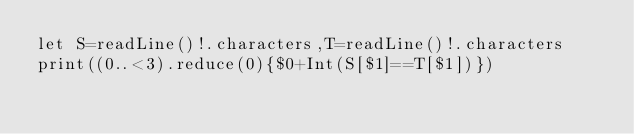Convert code to text. <code><loc_0><loc_0><loc_500><loc_500><_Swift_>let S=readLine()!.characters,T=readLine()!.characters
print((0..<3).reduce(0){$0+Int(S[$1]==T[$1])})</code> 